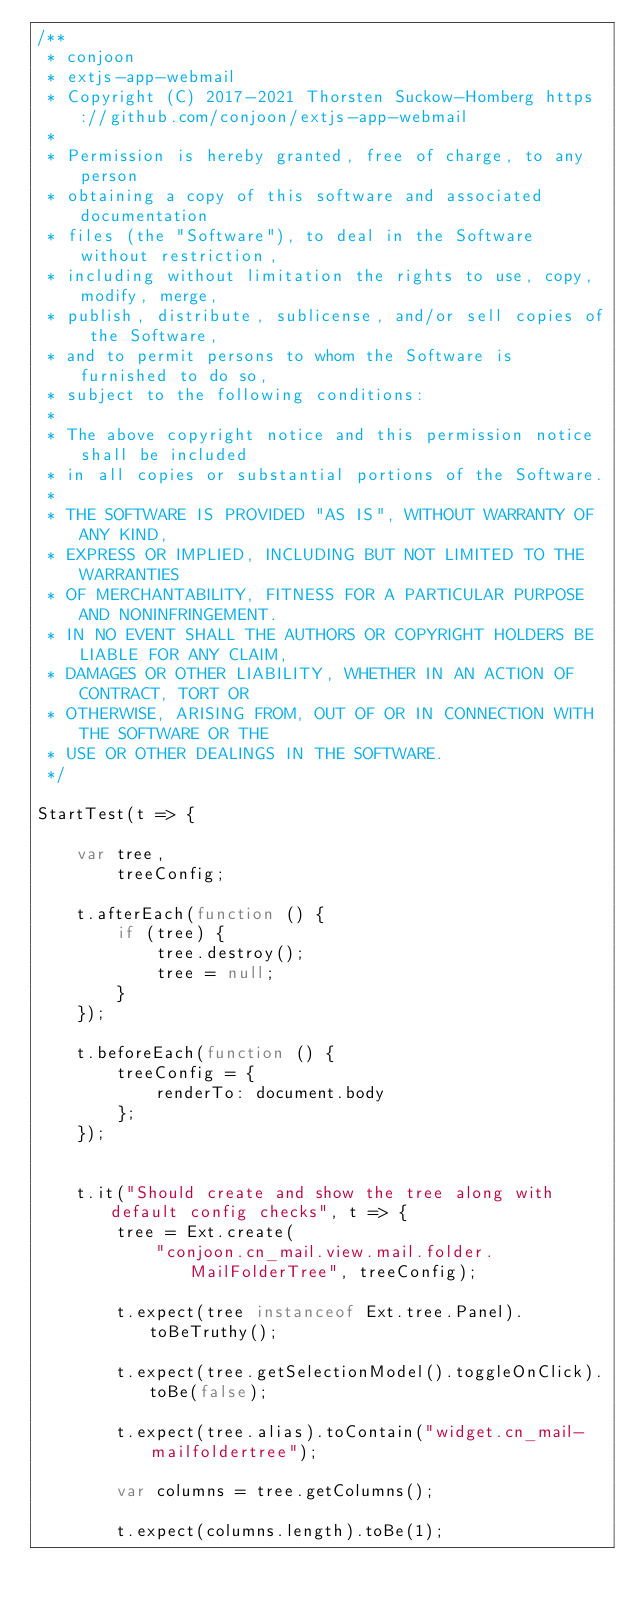<code> <loc_0><loc_0><loc_500><loc_500><_JavaScript_>/**
 * conjoon
 * extjs-app-webmail
 * Copyright (C) 2017-2021 Thorsten Suckow-Homberg https://github.com/conjoon/extjs-app-webmail
 *
 * Permission is hereby granted, free of charge, to any person
 * obtaining a copy of this software and associated documentation
 * files (the "Software"), to deal in the Software without restriction,
 * including without limitation the rights to use, copy, modify, merge,
 * publish, distribute, sublicense, and/or sell copies of the Software,
 * and to permit persons to whom the Software is furnished to do so,
 * subject to the following conditions:
 *
 * The above copyright notice and this permission notice shall be included
 * in all copies or substantial portions of the Software.
 *
 * THE SOFTWARE IS PROVIDED "AS IS", WITHOUT WARRANTY OF ANY KIND,
 * EXPRESS OR IMPLIED, INCLUDING BUT NOT LIMITED TO THE WARRANTIES
 * OF MERCHANTABILITY, FITNESS FOR A PARTICULAR PURPOSE AND NONINFRINGEMENT.
 * IN NO EVENT SHALL THE AUTHORS OR COPYRIGHT HOLDERS BE LIABLE FOR ANY CLAIM,
 * DAMAGES OR OTHER LIABILITY, WHETHER IN AN ACTION OF CONTRACT, TORT OR
 * OTHERWISE, ARISING FROM, OUT OF OR IN CONNECTION WITH THE SOFTWARE OR THE
 * USE OR OTHER DEALINGS IN THE SOFTWARE.
 */

StartTest(t => {

    var tree,
        treeConfig;

    t.afterEach(function () {
        if (tree) {
            tree.destroy();
            tree = null;
        }
    });

    t.beforeEach(function () {
        treeConfig = {
            renderTo: document.body
        };
    });


    t.it("Should create and show the tree along with default config checks", t => {
        tree = Ext.create(
            "conjoon.cn_mail.view.mail.folder.MailFolderTree", treeConfig);

        t.expect(tree instanceof Ext.tree.Panel).toBeTruthy();

        t.expect(tree.getSelectionModel().toggleOnClick).toBe(false);

        t.expect(tree.alias).toContain("widget.cn_mail-mailfoldertree");

        var columns = tree.getColumns();

        t.expect(columns.length).toBe(1);</code> 